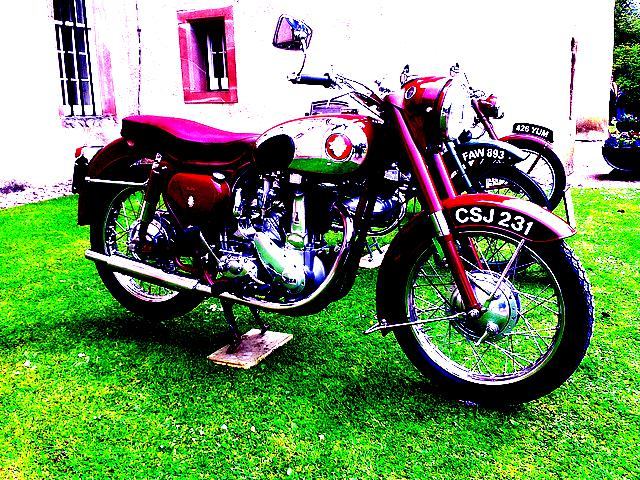Can you tell me the era or decade this motorcycle might be from? Judging by the design and style of the motorcycle, it looks like a classic model, potentially from the 1950s or 1960s. These types of bikes are known for their craftsmanship and timeless appeal. 